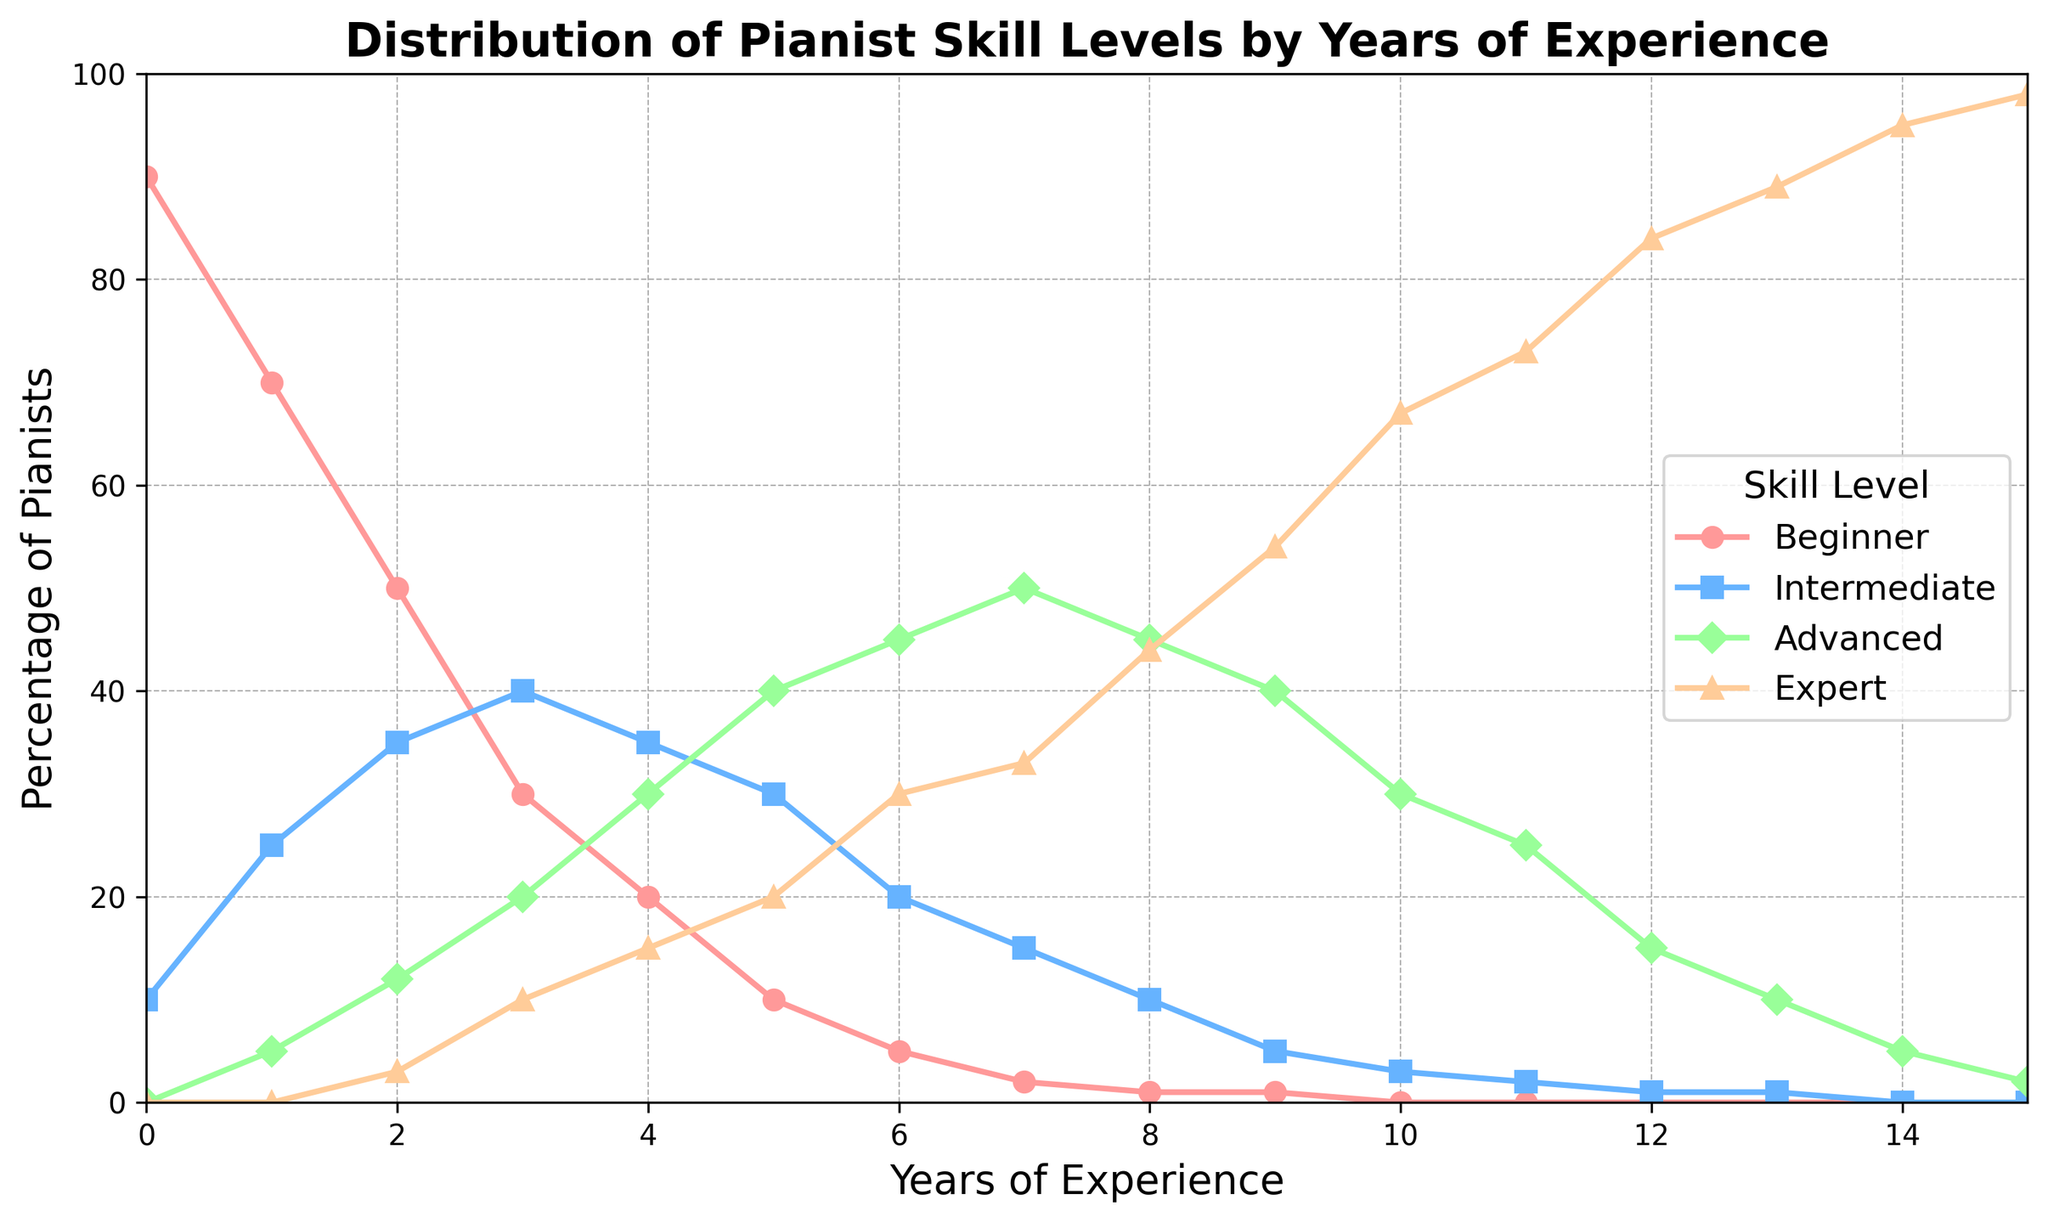What percentage of pianists with 3 years of experience are Beginners? Look for the data point corresponding to the "Beginner" level at 3 years of experience on the plot for "Years_of_Experience = 3".
Answer: 30% Which skill level shows the highest percentage of pianists with 9 years of experience? Identify which skill level has the highest data point at "Years_of_Experience = 9" by visual inspection of the plot.
Answer: Expert How does the percentage of Intermediate pianists change from 1 year to 7 years of experience? Determine the percentage of Intermediate pianists at 1 year and 7 years, then find the difference. The percentages are 25% at 1 year and 15% at 7 years.
Answer: Decreases by 10% What is the total percentage of Advanced pianists from 8 to 10 years of experience? Add the percentages of Advanced pianists at 8, 9, and 10 years of experience. They are 45%, 40%, and 30% respectively.
Answer: 115% Which skill level dominates as experience increases over the years? Observe the plot to see which skill level consistently has the highest percentage as the years of experience increase.
Answer: Expert Between which years of experience does the percentage of Expert pianists surpass 50% for the first time? Analyze the plot for the "Expert" line and find where it first exceeds 50%.
Answer: Between 9 and 10 years In the initial 3 years, which skill levels have their percentages decreasing? Check the plot for the trajectories of each skill level from 0 to 3 years and identify which ones decrease. Beginner decreases from 90% to 30%.
Answer: Beginner What is the difference in percentage between Advanced and Beginner pianists at 6 years of experience? Find the percentage for both Advanced (45%) and Beginner (5%) at 6 years, then calculate the difference.
Answer: 40% How does the percentage of Expert pianists compare from 12 to 15 years of experience? List the percentages of Expert pianists at 12, 13, 14, and 15 years, then compare them. They are 84%, 89%, 95%, and 98% respectively, showing an increasing trend.
Answer: Increasing 